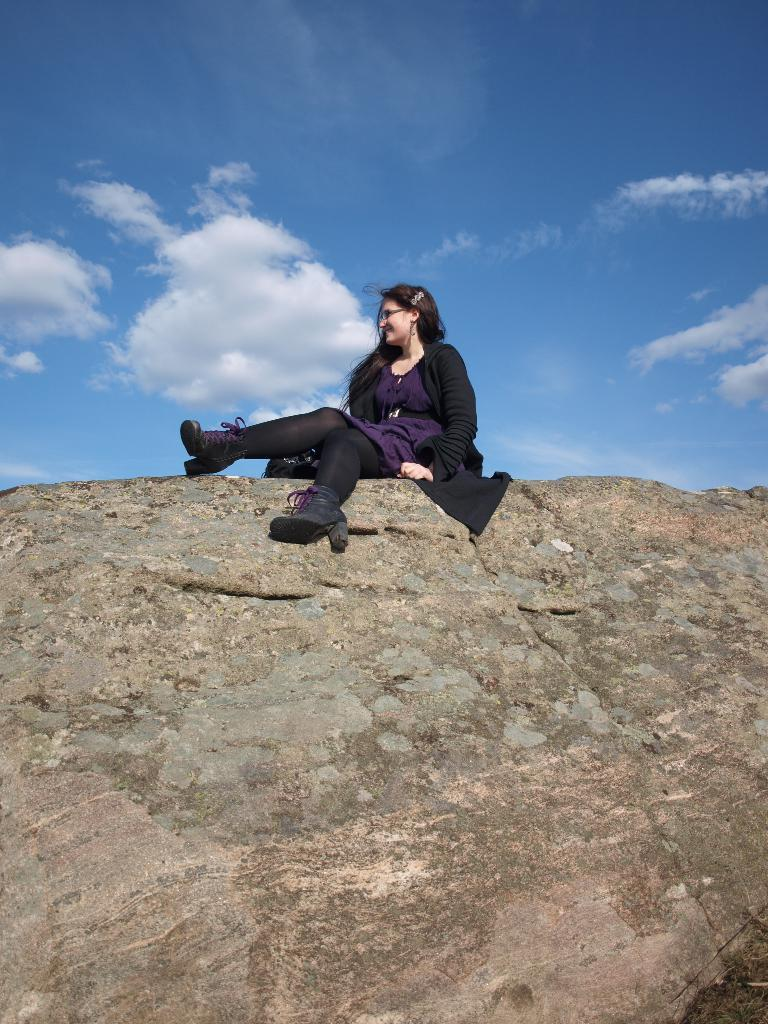Who is the main subject in the image? There is a woman in the image. What is the woman sitting on? The woman is sitting on a huge rock. What color is the woman's coat? The woman is wearing a black coat. What type of footwear is the woman wearing? The woman is wearing black boots. In which direction is the woman looking? The woman is looking towards her left. What can be seen in the background of the image? There is a sky visible in the background of the image. What story is the woman telling with her mouth in the image? There is no indication in the image that the woman is telling a story or using her mouth to communicate. 